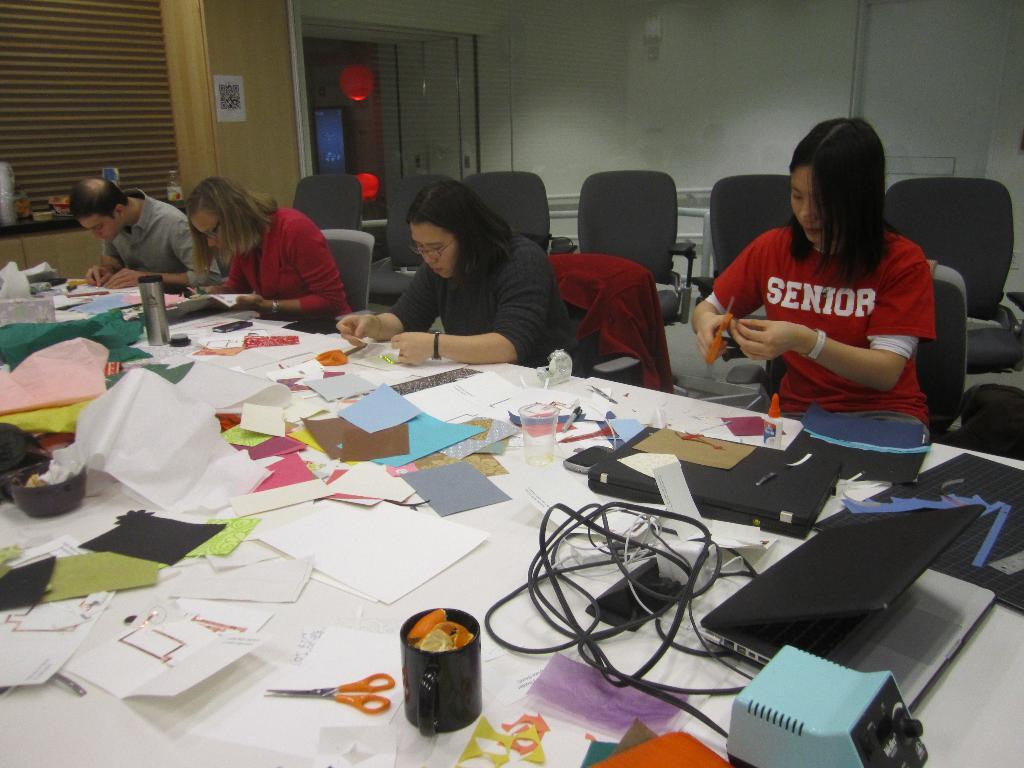Is the girl a senior?
Ensure brevity in your answer.  Yes. 